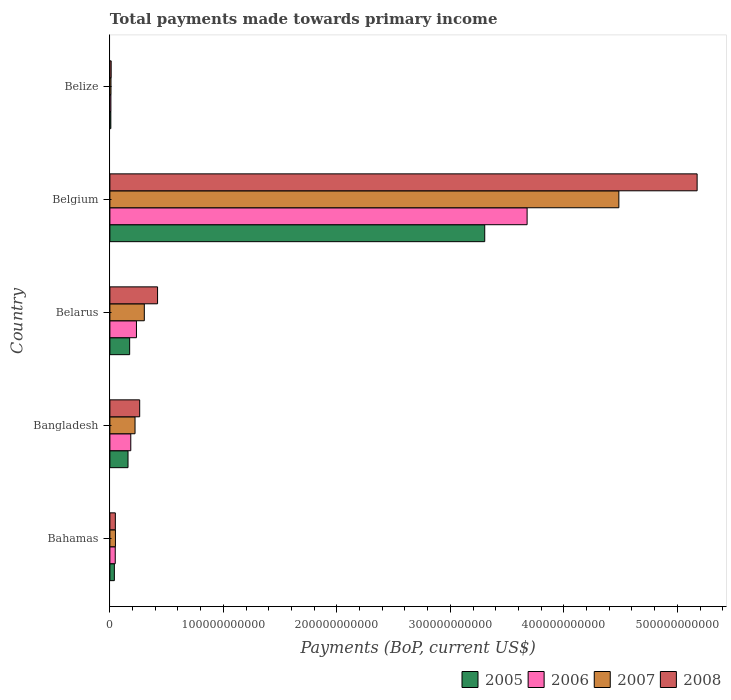How many different coloured bars are there?
Keep it short and to the point. 4. Are the number of bars per tick equal to the number of legend labels?
Provide a short and direct response. Yes. Are the number of bars on each tick of the Y-axis equal?
Provide a short and direct response. Yes. How many bars are there on the 3rd tick from the bottom?
Your response must be concise. 4. What is the label of the 1st group of bars from the top?
Your answer should be compact. Belize. In how many cases, is the number of bars for a given country not equal to the number of legend labels?
Ensure brevity in your answer.  0. What is the total payments made towards primary income in 2007 in Bahamas?
Your response must be concise. 4.89e+09. Across all countries, what is the maximum total payments made towards primary income in 2005?
Your response must be concise. 3.30e+11. Across all countries, what is the minimum total payments made towards primary income in 2006?
Your response must be concise. 8.85e+08. In which country was the total payments made towards primary income in 2006 maximum?
Keep it short and to the point. Belgium. In which country was the total payments made towards primary income in 2005 minimum?
Make the answer very short. Belize. What is the total total payments made towards primary income in 2006 in the graph?
Your answer should be very brief. 4.15e+11. What is the difference between the total payments made towards primary income in 2007 in Bangladesh and that in Belgium?
Ensure brevity in your answer.  -4.26e+11. What is the difference between the total payments made towards primary income in 2007 in Bahamas and the total payments made towards primary income in 2006 in Belize?
Your answer should be compact. 4.00e+09. What is the average total payments made towards primary income in 2008 per country?
Your answer should be very brief. 1.18e+11. What is the difference between the total payments made towards primary income in 2008 and total payments made towards primary income in 2006 in Belize?
Your answer should be compact. 2.44e+08. In how many countries, is the total payments made towards primary income in 2006 greater than 360000000000 US$?
Offer a very short reply. 1. What is the ratio of the total payments made towards primary income in 2007 in Bangladesh to that in Belarus?
Keep it short and to the point. 0.73. Is the total payments made towards primary income in 2008 in Bangladesh less than that in Belgium?
Your response must be concise. Yes. Is the difference between the total payments made towards primary income in 2008 in Belarus and Belize greater than the difference between the total payments made towards primary income in 2006 in Belarus and Belize?
Provide a succinct answer. Yes. What is the difference between the highest and the second highest total payments made towards primary income in 2007?
Your response must be concise. 4.18e+11. What is the difference between the highest and the lowest total payments made towards primary income in 2005?
Your response must be concise. 3.29e+11. How many bars are there?
Provide a short and direct response. 20. What is the difference between two consecutive major ticks on the X-axis?
Provide a short and direct response. 1.00e+11. Does the graph contain any zero values?
Ensure brevity in your answer.  No. How are the legend labels stacked?
Your answer should be very brief. Horizontal. What is the title of the graph?
Your answer should be compact. Total payments made towards primary income. Does "1988" appear as one of the legend labels in the graph?
Provide a succinct answer. No. What is the label or title of the X-axis?
Your answer should be compact. Payments (BoP, current US$). What is the label or title of the Y-axis?
Offer a terse response. Country. What is the Payments (BoP, current US$) in 2005 in Bahamas?
Make the answer very short. 3.94e+09. What is the Payments (BoP, current US$) of 2006 in Bahamas?
Make the answer very short. 4.71e+09. What is the Payments (BoP, current US$) of 2007 in Bahamas?
Ensure brevity in your answer.  4.89e+09. What is the Payments (BoP, current US$) in 2008 in Bahamas?
Keep it short and to the point. 4.80e+09. What is the Payments (BoP, current US$) in 2005 in Bangladesh?
Offer a terse response. 1.60e+1. What is the Payments (BoP, current US$) in 2006 in Bangladesh?
Your answer should be compact. 1.84e+1. What is the Payments (BoP, current US$) in 2007 in Bangladesh?
Provide a succinct answer. 2.22e+1. What is the Payments (BoP, current US$) in 2008 in Bangladesh?
Keep it short and to the point. 2.62e+1. What is the Payments (BoP, current US$) in 2005 in Belarus?
Offer a terse response. 1.74e+1. What is the Payments (BoP, current US$) in 2006 in Belarus?
Ensure brevity in your answer.  2.34e+1. What is the Payments (BoP, current US$) of 2007 in Belarus?
Keep it short and to the point. 3.03e+1. What is the Payments (BoP, current US$) in 2008 in Belarus?
Offer a terse response. 4.20e+1. What is the Payments (BoP, current US$) in 2005 in Belgium?
Keep it short and to the point. 3.30e+11. What is the Payments (BoP, current US$) in 2006 in Belgium?
Offer a terse response. 3.68e+11. What is the Payments (BoP, current US$) of 2007 in Belgium?
Make the answer very short. 4.48e+11. What is the Payments (BoP, current US$) in 2008 in Belgium?
Give a very brief answer. 5.17e+11. What is the Payments (BoP, current US$) of 2005 in Belize?
Make the answer very short. 8.24e+08. What is the Payments (BoP, current US$) of 2006 in Belize?
Make the answer very short. 8.85e+08. What is the Payments (BoP, current US$) in 2007 in Belize?
Provide a succinct answer. 9.69e+08. What is the Payments (BoP, current US$) of 2008 in Belize?
Your response must be concise. 1.13e+09. Across all countries, what is the maximum Payments (BoP, current US$) of 2005?
Your answer should be compact. 3.30e+11. Across all countries, what is the maximum Payments (BoP, current US$) of 2006?
Make the answer very short. 3.68e+11. Across all countries, what is the maximum Payments (BoP, current US$) in 2007?
Make the answer very short. 4.48e+11. Across all countries, what is the maximum Payments (BoP, current US$) of 2008?
Your response must be concise. 5.17e+11. Across all countries, what is the minimum Payments (BoP, current US$) of 2005?
Make the answer very short. 8.24e+08. Across all countries, what is the minimum Payments (BoP, current US$) in 2006?
Offer a terse response. 8.85e+08. Across all countries, what is the minimum Payments (BoP, current US$) in 2007?
Give a very brief answer. 9.69e+08. Across all countries, what is the minimum Payments (BoP, current US$) in 2008?
Provide a succinct answer. 1.13e+09. What is the total Payments (BoP, current US$) in 2005 in the graph?
Offer a very short reply. 3.68e+11. What is the total Payments (BoP, current US$) in 2006 in the graph?
Keep it short and to the point. 4.15e+11. What is the total Payments (BoP, current US$) in 2007 in the graph?
Offer a terse response. 5.07e+11. What is the total Payments (BoP, current US$) of 2008 in the graph?
Your answer should be compact. 5.92e+11. What is the difference between the Payments (BoP, current US$) of 2005 in Bahamas and that in Bangladesh?
Ensure brevity in your answer.  -1.20e+1. What is the difference between the Payments (BoP, current US$) of 2006 in Bahamas and that in Bangladesh?
Your answer should be very brief. -1.37e+1. What is the difference between the Payments (BoP, current US$) in 2007 in Bahamas and that in Bangladesh?
Your response must be concise. -1.73e+1. What is the difference between the Payments (BoP, current US$) in 2008 in Bahamas and that in Bangladesh?
Offer a terse response. -2.14e+1. What is the difference between the Payments (BoP, current US$) of 2005 in Bahamas and that in Belarus?
Ensure brevity in your answer.  -1.35e+1. What is the difference between the Payments (BoP, current US$) in 2006 in Bahamas and that in Belarus?
Your answer should be compact. -1.87e+1. What is the difference between the Payments (BoP, current US$) of 2007 in Bahamas and that in Belarus?
Keep it short and to the point. -2.54e+1. What is the difference between the Payments (BoP, current US$) in 2008 in Bahamas and that in Belarus?
Provide a succinct answer. -3.72e+1. What is the difference between the Payments (BoP, current US$) of 2005 in Bahamas and that in Belgium?
Offer a very short reply. -3.26e+11. What is the difference between the Payments (BoP, current US$) of 2006 in Bahamas and that in Belgium?
Keep it short and to the point. -3.63e+11. What is the difference between the Payments (BoP, current US$) of 2007 in Bahamas and that in Belgium?
Offer a very short reply. -4.44e+11. What is the difference between the Payments (BoP, current US$) of 2008 in Bahamas and that in Belgium?
Offer a terse response. -5.13e+11. What is the difference between the Payments (BoP, current US$) of 2005 in Bahamas and that in Belize?
Make the answer very short. 3.12e+09. What is the difference between the Payments (BoP, current US$) of 2006 in Bahamas and that in Belize?
Your answer should be compact. 3.83e+09. What is the difference between the Payments (BoP, current US$) of 2007 in Bahamas and that in Belize?
Your response must be concise. 3.92e+09. What is the difference between the Payments (BoP, current US$) in 2008 in Bahamas and that in Belize?
Make the answer very short. 3.67e+09. What is the difference between the Payments (BoP, current US$) of 2005 in Bangladesh and that in Belarus?
Keep it short and to the point. -1.44e+09. What is the difference between the Payments (BoP, current US$) in 2006 in Bangladesh and that in Belarus?
Provide a succinct answer. -5.01e+09. What is the difference between the Payments (BoP, current US$) in 2007 in Bangladesh and that in Belarus?
Your answer should be compact. -8.18e+09. What is the difference between the Payments (BoP, current US$) in 2008 in Bangladesh and that in Belarus?
Make the answer very short. -1.58e+1. What is the difference between the Payments (BoP, current US$) in 2005 in Bangladesh and that in Belgium?
Offer a terse response. -3.14e+11. What is the difference between the Payments (BoP, current US$) of 2006 in Bangladesh and that in Belgium?
Give a very brief answer. -3.49e+11. What is the difference between the Payments (BoP, current US$) of 2007 in Bangladesh and that in Belgium?
Provide a succinct answer. -4.26e+11. What is the difference between the Payments (BoP, current US$) of 2008 in Bangladesh and that in Belgium?
Give a very brief answer. -4.91e+11. What is the difference between the Payments (BoP, current US$) in 2005 in Bangladesh and that in Belize?
Your answer should be compact. 1.51e+1. What is the difference between the Payments (BoP, current US$) in 2006 in Bangladesh and that in Belize?
Your response must be concise. 1.75e+1. What is the difference between the Payments (BoP, current US$) in 2007 in Bangladesh and that in Belize?
Your response must be concise. 2.12e+1. What is the difference between the Payments (BoP, current US$) of 2008 in Bangladesh and that in Belize?
Keep it short and to the point. 2.51e+1. What is the difference between the Payments (BoP, current US$) in 2005 in Belarus and that in Belgium?
Your answer should be very brief. -3.13e+11. What is the difference between the Payments (BoP, current US$) of 2006 in Belarus and that in Belgium?
Ensure brevity in your answer.  -3.44e+11. What is the difference between the Payments (BoP, current US$) in 2007 in Belarus and that in Belgium?
Your answer should be very brief. -4.18e+11. What is the difference between the Payments (BoP, current US$) in 2008 in Belarus and that in Belgium?
Your answer should be compact. -4.75e+11. What is the difference between the Payments (BoP, current US$) of 2005 in Belarus and that in Belize?
Your response must be concise. 1.66e+1. What is the difference between the Payments (BoP, current US$) of 2006 in Belarus and that in Belize?
Offer a terse response. 2.25e+1. What is the difference between the Payments (BoP, current US$) in 2007 in Belarus and that in Belize?
Give a very brief answer. 2.94e+1. What is the difference between the Payments (BoP, current US$) in 2008 in Belarus and that in Belize?
Your answer should be very brief. 4.09e+1. What is the difference between the Payments (BoP, current US$) in 2005 in Belgium and that in Belize?
Your answer should be compact. 3.29e+11. What is the difference between the Payments (BoP, current US$) in 2006 in Belgium and that in Belize?
Give a very brief answer. 3.67e+11. What is the difference between the Payments (BoP, current US$) in 2007 in Belgium and that in Belize?
Make the answer very short. 4.47e+11. What is the difference between the Payments (BoP, current US$) in 2008 in Belgium and that in Belize?
Make the answer very short. 5.16e+11. What is the difference between the Payments (BoP, current US$) of 2005 in Bahamas and the Payments (BoP, current US$) of 2006 in Bangladesh?
Provide a short and direct response. -1.45e+1. What is the difference between the Payments (BoP, current US$) of 2005 in Bahamas and the Payments (BoP, current US$) of 2007 in Bangladesh?
Your answer should be very brief. -1.82e+1. What is the difference between the Payments (BoP, current US$) of 2005 in Bahamas and the Payments (BoP, current US$) of 2008 in Bangladesh?
Your answer should be compact. -2.23e+1. What is the difference between the Payments (BoP, current US$) in 2006 in Bahamas and the Payments (BoP, current US$) in 2007 in Bangladesh?
Ensure brevity in your answer.  -1.74e+1. What is the difference between the Payments (BoP, current US$) in 2006 in Bahamas and the Payments (BoP, current US$) in 2008 in Bangladesh?
Keep it short and to the point. -2.15e+1. What is the difference between the Payments (BoP, current US$) of 2007 in Bahamas and the Payments (BoP, current US$) of 2008 in Bangladesh?
Your response must be concise. -2.14e+1. What is the difference between the Payments (BoP, current US$) of 2005 in Bahamas and the Payments (BoP, current US$) of 2006 in Belarus?
Provide a succinct answer. -1.95e+1. What is the difference between the Payments (BoP, current US$) in 2005 in Bahamas and the Payments (BoP, current US$) in 2007 in Belarus?
Make the answer very short. -2.64e+1. What is the difference between the Payments (BoP, current US$) of 2005 in Bahamas and the Payments (BoP, current US$) of 2008 in Belarus?
Make the answer very short. -3.81e+1. What is the difference between the Payments (BoP, current US$) of 2006 in Bahamas and the Payments (BoP, current US$) of 2007 in Belarus?
Ensure brevity in your answer.  -2.56e+1. What is the difference between the Payments (BoP, current US$) in 2006 in Bahamas and the Payments (BoP, current US$) in 2008 in Belarus?
Ensure brevity in your answer.  -3.73e+1. What is the difference between the Payments (BoP, current US$) of 2007 in Bahamas and the Payments (BoP, current US$) of 2008 in Belarus?
Keep it short and to the point. -3.71e+1. What is the difference between the Payments (BoP, current US$) of 2005 in Bahamas and the Payments (BoP, current US$) of 2006 in Belgium?
Provide a short and direct response. -3.64e+11. What is the difference between the Payments (BoP, current US$) in 2005 in Bahamas and the Payments (BoP, current US$) in 2007 in Belgium?
Give a very brief answer. -4.45e+11. What is the difference between the Payments (BoP, current US$) in 2005 in Bahamas and the Payments (BoP, current US$) in 2008 in Belgium?
Provide a short and direct response. -5.13e+11. What is the difference between the Payments (BoP, current US$) of 2006 in Bahamas and the Payments (BoP, current US$) of 2007 in Belgium?
Provide a short and direct response. -4.44e+11. What is the difference between the Payments (BoP, current US$) of 2006 in Bahamas and the Payments (BoP, current US$) of 2008 in Belgium?
Make the answer very short. -5.13e+11. What is the difference between the Payments (BoP, current US$) in 2007 in Bahamas and the Payments (BoP, current US$) in 2008 in Belgium?
Offer a terse response. -5.13e+11. What is the difference between the Payments (BoP, current US$) of 2005 in Bahamas and the Payments (BoP, current US$) of 2006 in Belize?
Provide a succinct answer. 3.06e+09. What is the difference between the Payments (BoP, current US$) of 2005 in Bahamas and the Payments (BoP, current US$) of 2007 in Belize?
Your response must be concise. 2.97e+09. What is the difference between the Payments (BoP, current US$) in 2005 in Bahamas and the Payments (BoP, current US$) in 2008 in Belize?
Your answer should be compact. 2.81e+09. What is the difference between the Payments (BoP, current US$) of 2006 in Bahamas and the Payments (BoP, current US$) of 2007 in Belize?
Offer a terse response. 3.75e+09. What is the difference between the Payments (BoP, current US$) of 2006 in Bahamas and the Payments (BoP, current US$) of 2008 in Belize?
Your answer should be compact. 3.59e+09. What is the difference between the Payments (BoP, current US$) of 2007 in Bahamas and the Payments (BoP, current US$) of 2008 in Belize?
Provide a succinct answer. 3.76e+09. What is the difference between the Payments (BoP, current US$) of 2005 in Bangladesh and the Payments (BoP, current US$) of 2006 in Belarus?
Your answer should be very brief. -7.44e+09. What is the difference between the Payments (BoP, current US$) of 2005 in Bangladesh and the Payments (BoP, current US$) of 2007 in Belarus?
Keep it short and to the point. -1.44e+1. What is the difference between the Payments (BoP, current US$) of 2005 in Bangladesh and the Payments (BoP, current US$) of 2008 in Belarus?
Make the answer very short. -2.60e+1. What is the difference between the Payments (BoP, current US$) in 2006 in Bangladesh and the Payments (BoP, current US$) in 2007 in Belarus?
Keep it short and to the point. -1.19e+1. What is the difference between the Payments (BoP, current US$) of 2006 in Bangladesh and the Payments (BoP, current US$) of 2008 in Belarus?
Offer a terse response. -2.36e+1. What is the difference between the Payments (BoP, current US$) in 2007 in Bangladesh and the Payments (BoP, current US$) in 2008 in Belarus?
Keep it short and to the point. -1.99e+1. What is the difference between the Payments (BoP, current US$) in 2005 in Bangladesh and the Payments (BoP, current US$) in 2006 in Belgium?
Keep it short and to the point. -3.52e+11. What is the difference between the Payments (BoP, current US$) of 2005 in Bangladesh and the Payments (BoP, current US$) of 2007 in Belgium?
Ensure brevity in your answer.  -4.32e+11. What is the difference between the Payments (BoP, current US$) in 2005 in Bangladesh and the Payments (BoP, current US$) in 2008 in Belgium?
Offer a terse response. -5.01e+11. What is the difference between the Payments (BoP, current US$) in 2006 in Bangladesh and the Payments (BoP, current US$) in 2007 in Belgium?
Your answer should be compact. -4.30e+11. What is the difference between the Payments (BoP, current US$) of 2006 in Bangladesh and the Payments (BoP, current US$) of 2008 in Belgium?
Your answer should be very brief. -4.99e+11. What is the difference between the Payments (BoP, current US$) of 2007 in Bangladesh and the Payments (BoP, current US$) of 2008 in Belgium?
Ensure brevity in your answer.  -4.95e+11. What is the difference between the Payments (BoP, current US$) of 2005 in Bangladesh and the Payments (BoP, current US$) of 2006 in Belize?
Offer a terse response. 1.51e+1. What is the difference between the Payments (BoP, current US$) in 2005 in Bangladesh and the Payments (BoP, current US$) in 2007 in Belize?
Give a very brief answer. 1.50e+1. What is the difference between the Payments (BoP, current US$) of 2005 in Bangladesh and the Payments (BoP, current US$) of 2008 in Belize?
Provide a succinct answer. 1.48e+1. What is the difference between the Payments (BoP, current US$) in 2006 in Bangladesh and the Payments (BoP, current US$) in 2007 in Belize?
Provide a succinct answer. 1.74e+1. What is the difference between the Payments (BoP, current US$) of 2006 in Bangladesh and the Payments (BoP, current US$) of 2008 in Belize?
Your answer should be compact. 1.73e+1. What is the difference between the Payments (BoP, current US$) of 2007 in Bangladesh and the Payments (BoP, current US$) of 2008 in Belize?
Your answer should be compact. 2.10e+1. What is the difference between the Payments (BoP, current US$) of 2005 in Belarus and the Payments (BoP, current US$) of 2006 in Belgium?
Ensure brevity in your answer.  -3.50e+11. What is the difference between the Payments (BoP, current US$) in 2005 in Belarus and the Payments (BoP, current US$) in 2007 in Belgium?
Provide a succinct answer. -4.31e+11. What is the difference between the Payments (BoP, current US$) of 2005 in Belarus and the Payments (BoP, current US$) of 2008 in Belgium?
Give a very brief answer. -5.00e+11. What is the difference between the Payments (BoP, current US$) of 2006 in Belarus and the Payments (BoP, current US$) of 2007 in Belgium?
Ensure brevity in your answer.  -4.25e+11. What is the difference between the Payments (BoP, current US$) of 2006 in Belarus and the Payments (BoP, current US$) of 2008 in Belgium?
Provide a short and direct response. -4.94e+11. What is the difference between the Payments (BoP, current US$) of 2007 in Belarus and the Payments (BoP, current US$) of 2008 in Belgium?
Your answer should be very brief. -4.87e+11. What is the difference between the Payments (BoP, current US$) in 2005 in Belarus and the Payments (BoP, current US$) in 2006 in Belize?
Your answer should be compact. 1.65e+1. What is the difference between the Payments (BoP, current US$) of 2005 in Belarus and the Payments (BoP, current US$) of 2007 in Belize?
Provide a short and direct response. 1.64e+1. What is the difference between the Payments (BoP, current US$) in 2005 in Belarus and the Payments (BoP, current US$) in 2008 in Belize?
Your answer should be very brief. 1.63e+1. What is the difference between the Payments (BoP, current US$) in 2006 in Belarus and the Payments (BoP, current US$) in 2007 in Belize?
Your answer should be very brief. 2.24e+1. What is the difference between the Payments (BoP, current US$) of 2006 in Belarus and the Payments (BoP, current US$) of 2008 in Belize?
Keep it short and to the point. 2.23e+1. What is the difference between the Payments (BoP, current US$) of 2007 in Belarus and the Payments (BoP, current US$) of 2008 in Belize?
Give a very brief answer. 2.92e+1. What is the difference between the Payments (BoP, current US$) in 2005 in Belgium and the Payments (BoP, current US$) in 2006 in Belize?
Offer a terse response. 3.29e+11. What is the difference between the Payments (BoP, current US$) of 2005 in Belgium and the Payments (BoP, current US$) of 2007 in Belize?
Give a very brief answer. 3.29e+11. What is the difference between the Payments (BoP, current US$) of 2005 in Belgium and the Payments (BoP, current US$) of 2008 in Belize?
Your answer should be very brief. 3.29e+11. What is the difference between the Payments (BoP, current US$) of 2006 in Belgium and the Payments (BoP, current US$) of 2007 in Belize?
Give a very brief answer. 3.67e+11. What is the difference between the Payments (BoP, current US$) of 2006 in Belgium and the Payments (BoP, current US$) of 2008 in Belize?
Offer a terse response. 3.66e+11. What is the difference between the Payments (BoP, current US$) of 2007 in Belgium and the Payments (BoP, current US$) of 2008 in Belize?
Make the answer very short. 4.47e+11. What is the average Payments (BoP, current US$) of 2005 per country?
Offer a terse response. 7.37e+1. What is the average Payments (BoP, current US$) in 2006 per country?
Ensure brevity in your answer.  8.30e+1. What is the average Payments (BoP, current US$) in 2007 per country?
Offer a terse response. 1.01e+11. What is the average Payments (BoP, current US$) of 2008 per country?
Offer a terse response. 1.18e+11. What is the difference between the Payments (BoP, current US$) in 2005 and Payments (BoP, current US$) in 2006 in Bahamas?
Provide a succinct answer. -7.72e+08. What is the difference between the Payments (BoP, current US$) in 2005 and Payments (BoP, current US$) in 2007 in Bahamas?
Offer a very short reply. -9.46e+08. What is the difference between the Payments (BoP, current US$) in 2005 and Payments (BoP, current US$) in 2008 in Bahamas?
Keep it short and to the point. -8.58e+08. What is the difference between the Payments (BoP, current US$) of 2006 and Payments (BoP, current US$) of 2007 in Bahamas?
Keep it short and to the point. -1.75e+08. What is the difference between the Payments (BoP, current US$) of 2006 and Payments (BoP, current US$) of 2008 in Bahamas?
Make the answer very short. -8.58e+07. What is the difference between the Payments (BoP, current US$) in 2007 and Payments (BoP, current US$) in 2008 in Bahamas?
Your answer should be compact. 8.88e+07. What is the difference between the Payments (BoP, current US$) of 2005 and Payments (BoP, current US$) of 2006 in Bangladesh?
Your answer should be very brief. -2.43e+09. What is the difference between the Payments (BoP, current US$) of 2005 and Payments (BoP, current US$) of 2007 in Bangladesh?
Provide a succinct answer. -6.18e+09. What is the difference between the Payments (BoP, current US$) of 2005 and Payments (BoP, current US$) of 2008 in Bangladesh?
Provide a succinct answer. -1.03e+1. What is the difference between the Payments (BoP, current US$) of 2006 and Payments (BoP, current US$) of 2007 in Bangladesh?
Make the answer very short. -3.75e+09. What is the difference between the Payments (BoP, current US$) in 2006 and Payments (BoP, current US$) in 2008 in Bangladesh?
Your response must be concise. -7.85e+09. What is the difference between the Payments (BoP, current US$) of 2007 and Payments (BoP, current US$) of 2008 in Bangladesh?
Give a very brief answer. -4.10e+09. What is the difference between the Payments (BoP, current US$) of 2005 and Payments (BoP, current US$) of 2006 in Belarus?
Give a very brief answer. -6.00e+09. What is the difference between the Payments (BoP, current US$) of 2005 and Payments (BoP, current US$) of 2007 in Belarus?
Provide a short and direct response. -1.29e+1. What is the difference between the Payments (BoP, current US$) in 2005 and Payments (BoP, current US$) in 2008 in Belarus?
Offer a very short reply. -2.46e+1. What is the difference between the Payments (BoP, current US$) in 2006 and Payments (BoP, current US$) in 2007 in Belarus?
Provide a short and direct response. -6.92e+09. What is the difference between the Payments (BoP, current US$) of 2006 and Payments (BoP, current US$) of 2008 in Belarus?
Make the answer very short. -1.86e+1. What is the difference between the Payments (BoP, current US$) of 2007 and Payments (BoP, current US$) of 2008 in Belarus?
Make the answer very short. -1.17e+1. What is the difference between the Payments (BoP, current US$) of 2005 and Payments (BoP, current US$) of 2006 in Belgium?
Make the answer very short. -3.73e+1. What is the difference between the Payments (BoP, current US$) in 2005 and Payments (BoP, current US$) in 2007 in Belgium?
Ensure brevity in your answer.  -1.18e+11. What is the difference between the Payments (BoP, current US$) in 2005 and Payments (BoP, current US$) in 2008 in Belgium?
Make the answer very short. -1.87e+11. What is the difference between the Payments (BoP, current US$) of 2006 and Payments (BoP, current US$) of 2007 in Belgium?
Your answer should be compact. -8.08e+1. What is the difference between the Payments (BoP, current US$) in 2006 and Payments (BoP, current US$) in 2008 in Belgium?
Offer a terse response. -1.50e+11. What is the difference between the Payments (BoP, current US$) in 2007 and Payments (BoP, current US$) in 2008 in Belgium?
Give a very brief answer. -6.90e+1. What is the difference between the Payments (BoP, current US$) in 2005 and Payments (BoP, current US$) in 2006 in Belize?
Keep it short and to the point. -6.12e+07. What is the difference between the Payments (BoP, current US$) in 2005 and Payments (BoP, current US$) in 2007 in Belize?
Provide a short and direct response. -1.45e+08. What is the difference between the Payments (BoP, current US$) of 2005 and Payments (BoP, current US$) of 2008 in Belize?
Give a very brief answer. -3.05e+08. What is the difference between the Payments (BoP, current US$) of 2006 and Payments (BoP, current US$) of 2007 in Belize?
Your response must be concise. -8.34e+07. What is the difference between the Payments (BoP, current US$) of 2006 and Payments (BoP, current US$) of 2008 in Belize?
Give a very brief answer. -2.44e+08. What is the difference between the Payments (BoP, current US$) in 2007 and Payments (BoP, current US$) in 2008 in Belize?
Your response must be concise. -1.60e+08. What is the ratio of the Payments (BoP, current US$) of 2005 in Bahamas to that in Bangladesh?
Ensure brevity in your answer.  0.25. What is the ratio of the Payments (BoP, current US$) of 2006 in Bahamas to that in Bangladesh?
Offer a terse response. 0.26. What is the ratio of the Payments (BoP, current US$) of 2007 in Bahamas to that in Bangladesh?
Your answer should be compact. 0.22. What is the ratio of the Payments (BoP, current US$) in 2008 in Bahamas to that in Bangladesh?
Offer a terse response. 0.18. What is the ratio of the Payments (BoP, current US$) of 2005 in Bahamas to that in Belarus?
Ensure brevity in your answer.  0.23. What is the ratio of the Payments (BoP, current US$) in 2006 in Bahamas to that in Belarus?
Ensure brevity in your answer.  0.2. What is the ratio of the Payments (BoP, current US$) in 2007 in Bahamas to that in Belarus?
Offer a very short reply. 0.16. What is the ratio of the Payments (BoP, current US$) of 2008 in Bahamas to that in Belarus?
Your answer should be compact. 0.11. What is the ratio of the Payments (BoP, current US$) in 2005 in Bahamas to that in Belgium?
Give a very brief answer. 0.01. What is the ratio of the Payments (BoP, current US$) in 2006 in Bahamas to that in Belgium?
Your response must be concise. 0.01. What is the ratio of the Payments (BoP, current US$) of 2007 in Bahamas to that in Belgium?
Your answer should be compact. 0.01. What is the ratio of the Payments (BoP, current US$) in 2008 in Bahamas to that in Belgium?
Offer a terse response. 0.01. What is the ratio of the Payments (BoP, current US$) in 2005 in Bahamas to that in Belize?
Offer a very short reply. 4.78. What is the ratio of the Payments (BoP, current US$) of 2006 in Bahamas to that in Belize?
Provide a succinct answer. 5.32. What is the ratio of the Payments (BoP, current US$) in 2007 in Bahamas to that in Belize?
Your answer should be compact. 5.05. What is the ratio of the Payments (BoP, current US$) in 2008 in Bahamas to that in Belize?
Offer a terse response. 4.25. What is the ratio of the Payments (BoP, current US$) of 2005 in Bangladesh to that in Belarus?
Ensure brevity in your answer.  0.92. What is the ratio of the Payments (BoP, current US$) of 2006 in Bangladesh to that in Belarus?
Give a very brief answer. 0.79. What is the ratio of the Payments (BoP, current US$) in 2007 in Bangladesh to that in Belarus?
Your answer should be compact. 0.73. What is the ratio of the Payments (BoP, current US$) of 2008 in Bangladesh to that in Belarus?
Provide a short and direct response. 0.62. What is the ratio of the Payments (BoP, current US$) of 2005 in Bangladesh to that in Belgium?
Provide a short and direct response. 0.05. What is the ratio of the Payments (BoP, current US$) in 2006 in Bangladesh to that in Belgium?
Your answer should be very brief. 0.05. What is the ratio of the Payments (BoP, current US$) in 2007 in Bangladesh to that in Belgium?
Make the answer very short. 0.05. What is the ratio of the Payments (BoP, current US$) of 2008 in Bangladesh to that in Belgium?
Give a very brief answer. 0.05. What is the ratio of the Payments (BoP, current US$) of 2005 in Bangladesh to that in Belize?
Your response must be concise. 19.38. What is the ratio of the Payments (BoP, current US$) in 2006 in Bangladesh to that in Belize?
Ensure brevity in your answer.  20.78. What is the ratio of the Payments (BoP, current US$) of 2007 in Bangladesh to that in Belize?
Provide a succinct answer. 22.87. What is the ratio of the Payments (BoP, current US$) of 2008 in Bangladesh to that in Belize?
Offer a terse response. 23.25. What is the ratio of the Payments (BoP, current US$) of 2005 in Belarus to that in Belgium?
Make the answer very short. 0.05. What is the ratio of the Payments (BoP, current US$) in 2006 in Belarus to that in Belgium?
Your response must be concise. 0.06. What is the ratio of the Payments (BoP, current US$) in 2007 in Belarus to that in Belgium?
Make the answer very short. 0.07. What is the ratio of the Payments (BoP, current US$) in 2008 in Belarus to that in Belgium?
Keep it short and to the point. 0.08. What is the ratio of the Payments (BoP, current US$) in 2005 in Belarus to that in Belize?
Offer a terse response. 21.12. What is the ratio of the Payments (BoP, current US$) in 2006 in Belarus to that in Belize?
Provide a succinct answer. 26.44. What is the ratio of the Payments (BoP, current US$) of 2007 in Belarus to that in Belize?
Provide a short and direct response. 31.31. What is the ratio of the Payments (BoP, current US$) in 2008 in Belarus to that in Belize?
Your answer should be compact. 37.21. What is the ratio of the Payments (BoP, current US$) of 2005 in Belgium to that in Belize?
Provide a succinct answer. 400.72. What is the ratio of the Payments (BoP, current US$) of 2006 in Belgium to that in Belize?
Your answer should be compact. 415.18. What is the ratio of the Payments (BoP, current US$) of 2007 in Belgium to that in Belize?
Offer a very short reply. 462.9. What is the ratio of the Payments (BoP, current US$) in 2008 in Belgium to that in Belize?
Your response must be concise. 458.33. What is the difference between the highest and the second highest Payments (BoP, current US$) of 2005?
Provide a short and direct response. 3.13e+11. What is the difference between the highest and the second highest Payments (BoP, current US$) in 2006?
Ensure brevity in your answer.  3.44e+11. What is the difference between the highest and the second highest Payments (BoP, current US$) in 2007?
Give a very brief answer. 4.18e+11. What is the difference between the highest and the second highest Payments (BoP, current US$) of 2008?
Your response must be concise. 4.75e+11. What is the difference between the highest and the lowest Payments (BoP, current US$) in 2005?
Ensure brevity in your answer.  3.29e+11. What is the difference between the highest and the lowest Payments (BoP, current US$) of 2006?
Provide a short and direct response. 3.67e+11. What is the difference between the highest and the lowest Payments (BoP, current US$) in 2007?
Offer a very short reply. 4.47e+11. What is the difference between the highest and the lowest Payments (BoP, current US$) in 2008?
Your answer should be very brief. 5.16e+11. 